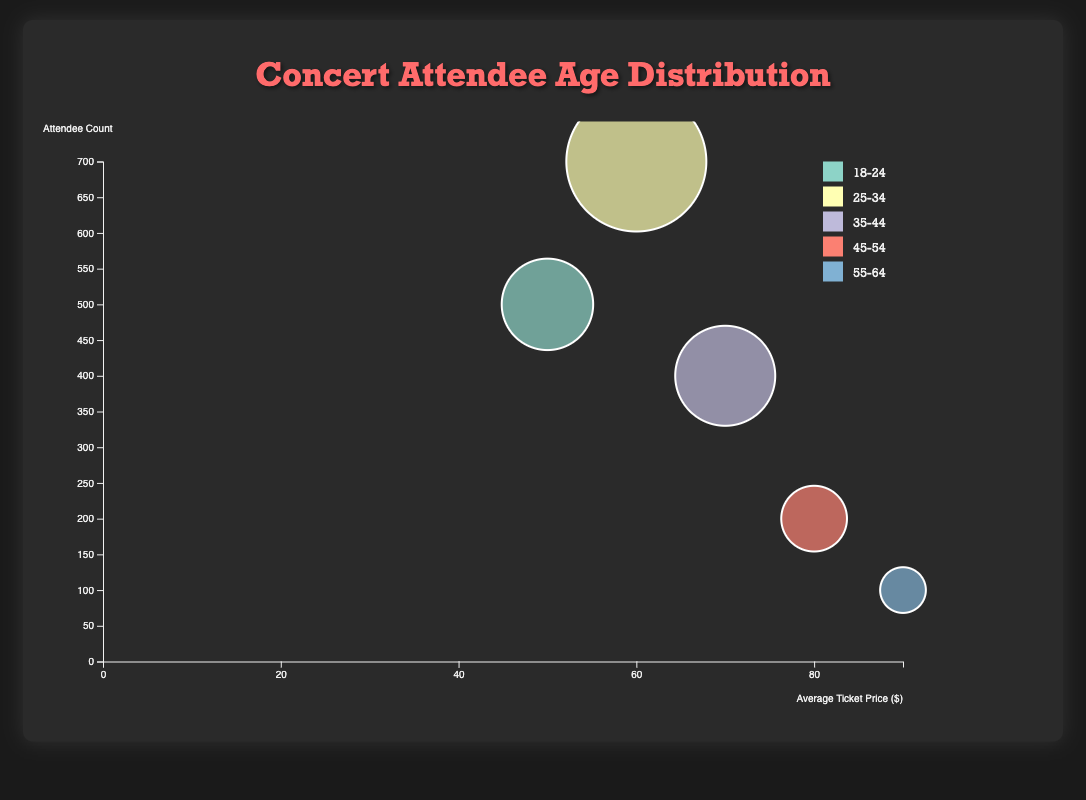what is the title of the figure? The title is located at the top of the figure, indicating the overall subject of the chart. It reads "Concert Attendee Age Distribution".
Answer: Concert Attendee Age Distribution what are the x and y axes labels respectively? The labels on the x and y axes describe the data being measured. The x-axis is labeled "Average Ticket Price ($)" and the y-axis is labeled "Attendee Count".
Answer: Average Ticket Price ($), Attendee Count which age group has the highest attendee count? By examining the y-axis and looking for the bubble positioned highest on the chart, the "25-34" age group has the highest attendee count of 700.
Answer: 25-34 how many safety incidents did the age group 18-24 experience in total? Each bubble represents data points including safety incidents. The tooltip data indicates that the "18-24" age group experienced 5 safety incidents.
Answer: 5 which age group recorded the lowest safety incidents? Looking at the tooltip information for each bubble, "45-54" and "55-64" both recorded 0 safety incidents.
Answer: 45-54 and 55-64 what is the difference in attendee count between the age groups 25-34 and 35-44? Subtract the number of attendees of the "35-44" age group (400) from that of the "25-34" age group (700). 700 - 400 = 300
Answer: 300 which age group generated the highest revenue? The size of the bubble indicates revenue; the largest bubble belongs to the "25-34" age group with $42,000 revenue.
Answer: 25-34 how does the number of safety incidents compare between the age group with the highest and lowest attendee counts? The "25-34" age group has the highest attendee count (700) with 3 safety incidents, while the "55-64" group has the lowest attendee count (100) with 0 safety incidents.
Answer: 3 vs. 0 how does the average ticket price trend as the age group increases? By observing the x-axis position of bubbles correlating to age groups, the average ticket price tends to increase with older age groups, from $50 for "18-24" up to $90 for "55-64".
Answer: Increases which age group has a greater attendee count: 18-24 or 45-54? By comparing the y-axis positions, the "18-24" age group has an attendee count of 500, whereas the "45-54" age group has an attendee count of 200. Thus, "18-24" has a greater count.
Answer: 18-24 